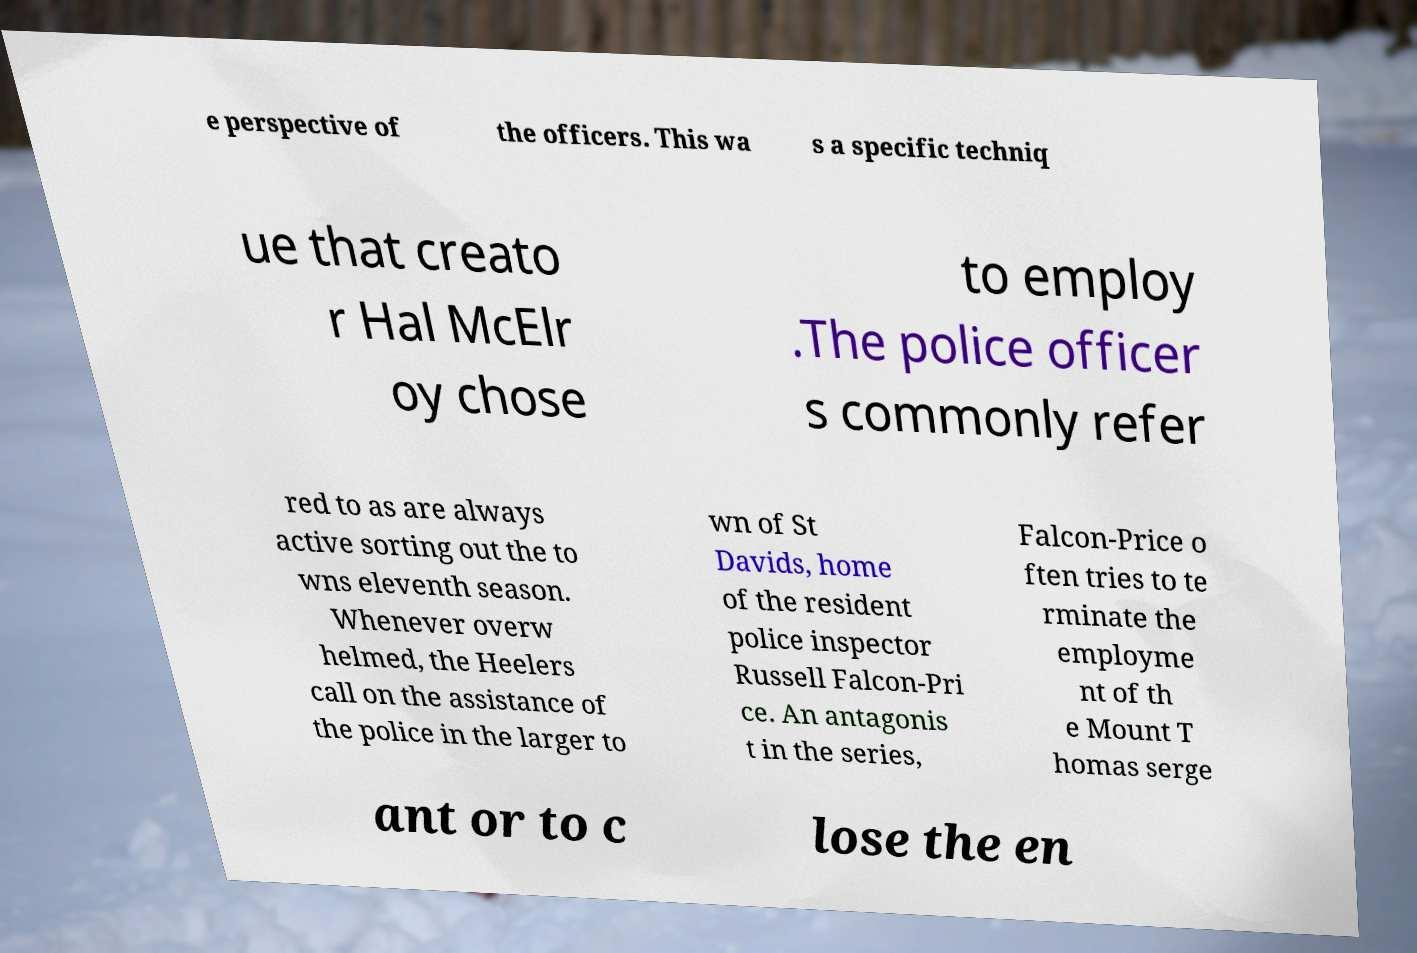Please read and relay the text visible in this image. What does it say? e perspective of the officers. This wa s a specific techniq ue that creato r Hal McElr oy chose to employ .The police officer s commonly refer red to as are always active sorting out the to wns eleventh season. Whenever overw helmed, the Heelers call on the assistance of the police in the larger to wn of St Davids, home of the resident police inspector Russell Falcon-Pri ce. An antagonis t in the series, Falcon-Price o ften tries to te rminate the employme nt of th e Mount T homas serge ant or to c lose the en 